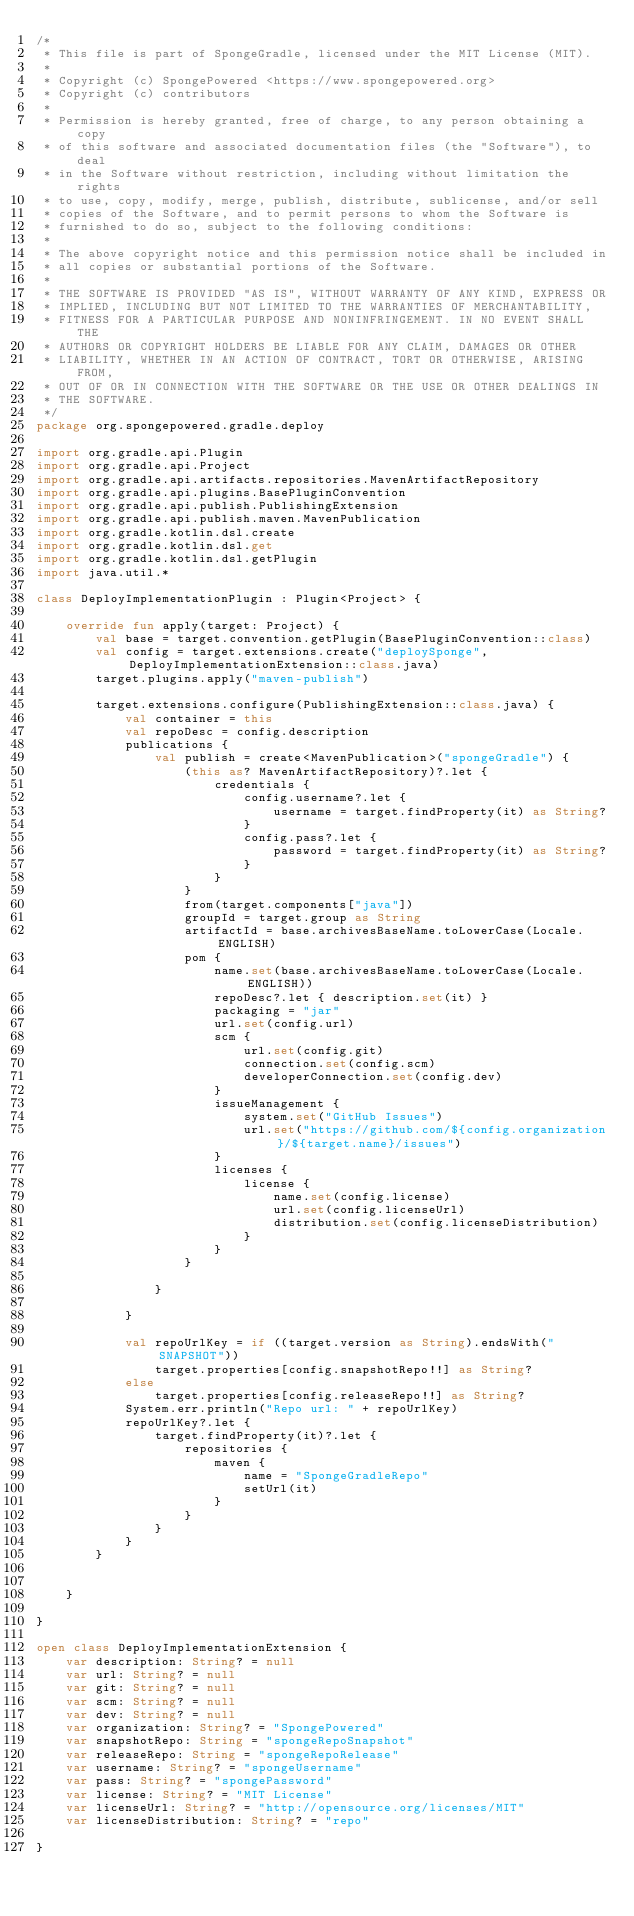Convert code to text. <code><loc_0><loc_0><loc_500><loc_500><_Kotlin_>/*
 * This file is part of SpongeGradle, licensed under the MIT License (MIT).
 *
 * Copyright (c) SpongePowered <https://www.spongepowered.org>
 * Copyright (c) contributors
 *
 * Permission is hereby granted, free of charge, to any person obtaining a copy
 * of this software and associated documentation files (the "Software"), to deal
 * in the Software without restriction, including without limitation the rights
 * to use, copy, modify, merge, publish, distribute, sublicense, and/or sell
 * copies of the Software, and to permit persons to whom the Software is
 * furnished to do so, subject to the following conditions:
 *
 * The above copyright notice and this permission notice shall be included in
 * all copies or substantial portions of the Software.
 *
 * THE SOFTWARE IS PROVIDED "AS IS", WITHOUT WARRANTY OF ANY KIND, EXPRESS OR
 * IMPLIED, INCLUDING BUT NOT LIMITED TO THE WARRANTIES OF MERCHANTABILITY,
 * FITNESS FOR A PARTICULAR PURPOSE AND NONINFRINGEMENT. IN NO EVENT SHALL THE
 * AUTHORS OR COPYRIGHT HOLDERS BE LIABLE FOR ANY CLAIM, DAMAGES OR OTHER
 * LIABILITY, WHETHER IN AN ACTION OF CONTRACT, TORT OR OTHERWISE, ARISING FROM,
 * OUT OF OR IN CONNECTION WITH THE SOFTWARE OR THE USE OR OTHER DEALINGS IN
 * THE SOFTWARE.
 */
package org.spongepowered.gradle.deploy

import org.gradle.api.Plugin
import org.gradle.api.Project
import org.gradle.api.artifacts.repositories.MavenArtifactRepository
import org.gradle.api.plugins.BasePluginConvention
import org.gradle.api.publish.PublishingExtension
import org.gradle.api.publish.maven.MavenPublication
import org.gradle.kotlin.dsl.create
import org.gradle.kotlin.dsl.get
import org.gradle.kotlin.dsl.getPlugin
import java.util.*

class DeployImplementationPlugin : Plugin<Project> {

    override fun apply(target: Project) {
        val base = target.convention.getPlugin(BasePluginConvention::class)
        val config = target.extensions.create("deploySponge", DeployImplementationExtension::class.java)
        target.plugins.apply("maven-publish")

        target.extensions.configure(PublishingExtension::class.java) {
            val container = this
            val repoDesc = config.description
            publications {
                val publish = create<MavenPublication>("spongeGradle") {
                    (this as? MavenArtifactRepository)?.let {
                        credentials {
                            config.username?.let {
                                username = target.findProperty(it) as String?
                            }
                            config.pass?.let {
                                password = target.findProperty(it) as String?
                            }
                        }
                    }
                    from(target.components["java"])
                    groupId = target.group as String
                    artifactId = base.archivesBaseName.toLowerCase(Locale.ENGLISH)
                    pom {
                        name.set(base.archivesBaseName.toLowerCase(Locale.ENGLISH))
                        repoDesc?.let { description.set(it) }
                        packaging = "jar"
                        url.set(config.url)
                        scm {
                            url.set(config.git)
                            connection.set(config.scm)
                            developerConnection.set(config.dev)
                        }
                        issueManagement {
                            system.set("GitHub Issues")
                            url.set("https://github.com/${config.organization}/${target.name}/issues")
                        }
                        licenses {
                            license {
                                name.set(config.license)
                                url.set(config.licenseUrl)
                                distribution.set(config.licenseDistribution)
                            }
                        }
                    }

                }

            }

            val repoUrlKey = if ((target.version as String).endsWith("SNAPSHOT"))
                target.properties[config.snapshotRepo!!] as String?
            else
                target.properties[config.releaseRepo!!] as String?
            System.err.println("Repo url: " + repoUrlKey)
            repoUrlKey?.let {
                target.findProperty(it)?.let {
                    repositories {
                        maven {
                            name = "SpongeGradleRepo"
                            setUrl(it)
                        }
                    }
                }
            }
        }


    }

}

open class DeployImplementationExtension {
    var description: String? = null
    var url: String? = null
    var git: String? = null
    var scm: String? = null
    var dev: String? = null
    var organization: String? = "SpongePowered"
    var snapshotRepo: String = "spongeRepoSnapshot"
    var releaseRepo: String = "spongeRepoRelease"
    var username: String? = "spongeUsername"
    var pass: String? = "spongePassword"
    var license: String? = "MIT License"
    var licenseUrl: String? = "http://opensource.org/licenses/MIT"
    var licenseDistribution: String? = "repo"

}
</code> 